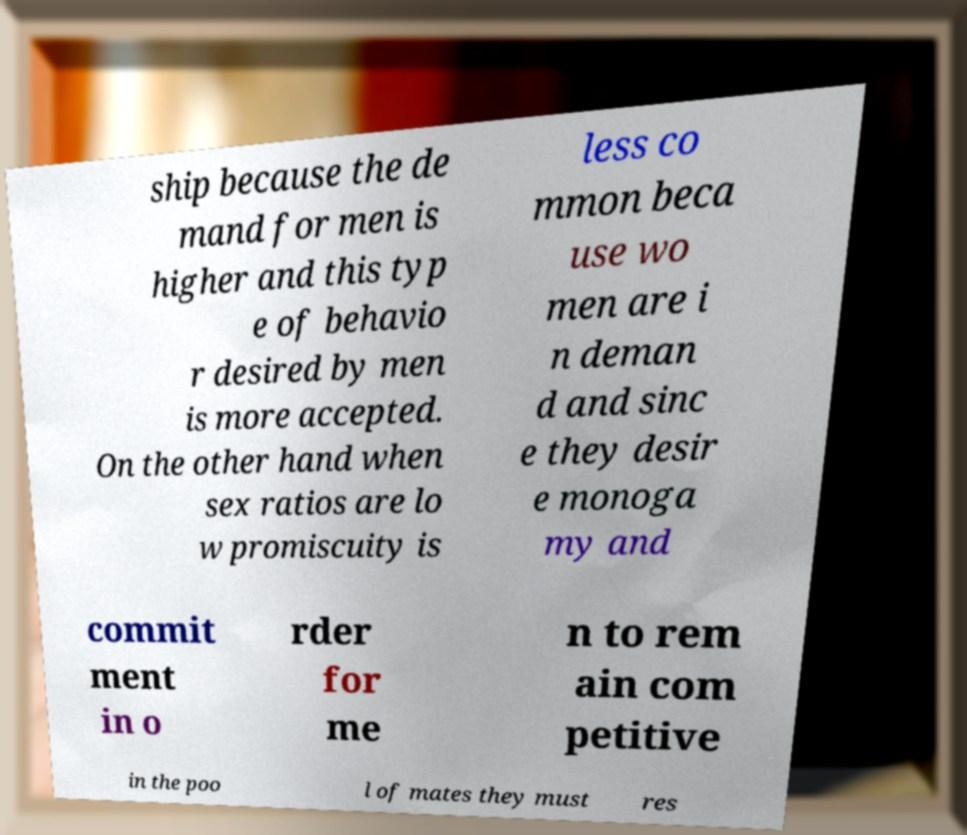Could you assist in decoding the text presented in this image and type it out clearly? ship because the de mand for men is higher and this typ e of behavio r desired by men is more accepted. On the other hand when sex ratios are lo w promiscuity is less co mmon beca use wo men are i n deman d and sinc e they desir e monoga my and commit ment in o rder for me n to rem ain com petitive in the poo l of mates they must res 